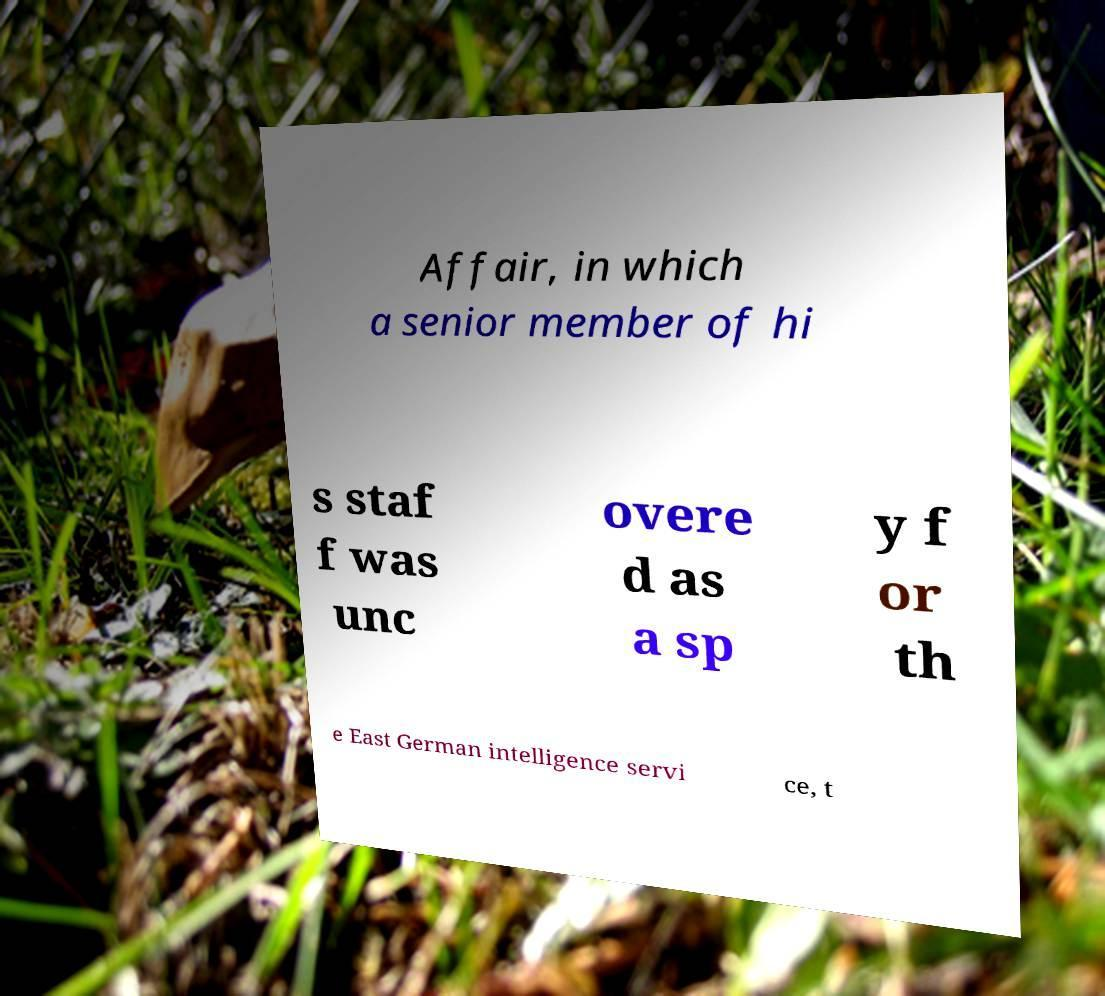Could you extract and type out the text from this image? Affair, in which a senior member of hi s staf f was unc overe d as a sp y f or th e East German intelligence servi ce, t 